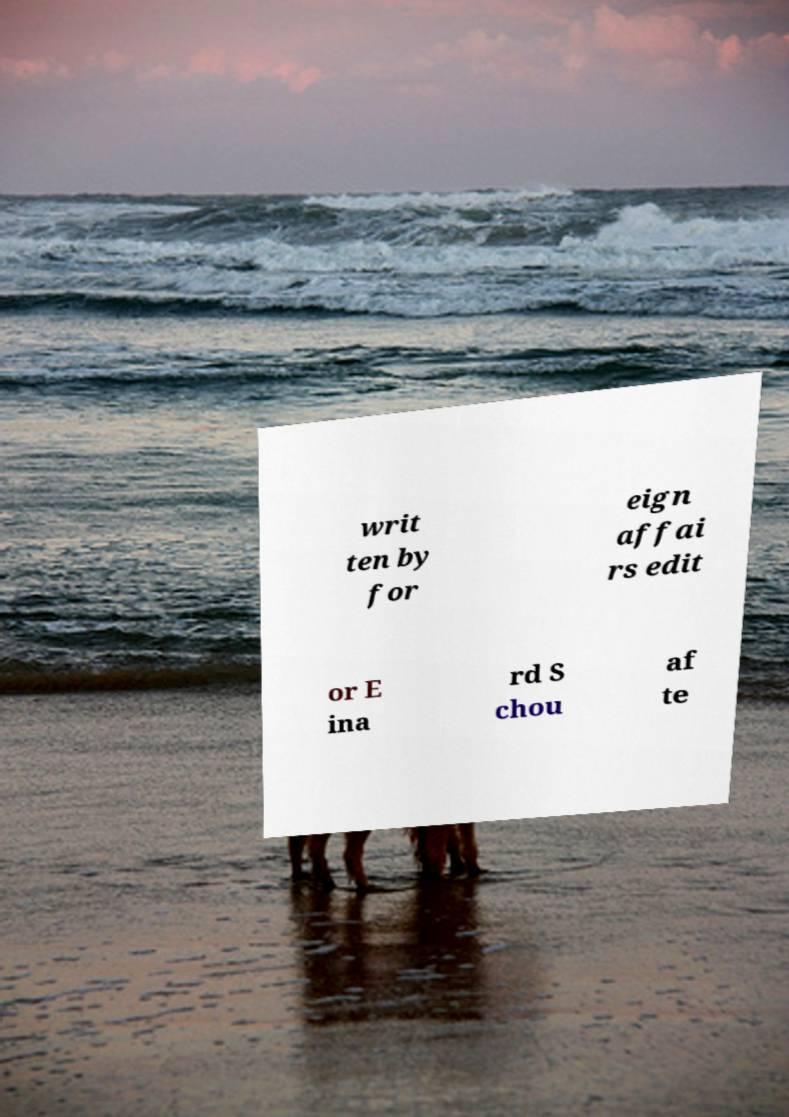Could you extract and type out the text from this image? writ ten by for eign affai rs edit or E ina rd S chou af te 